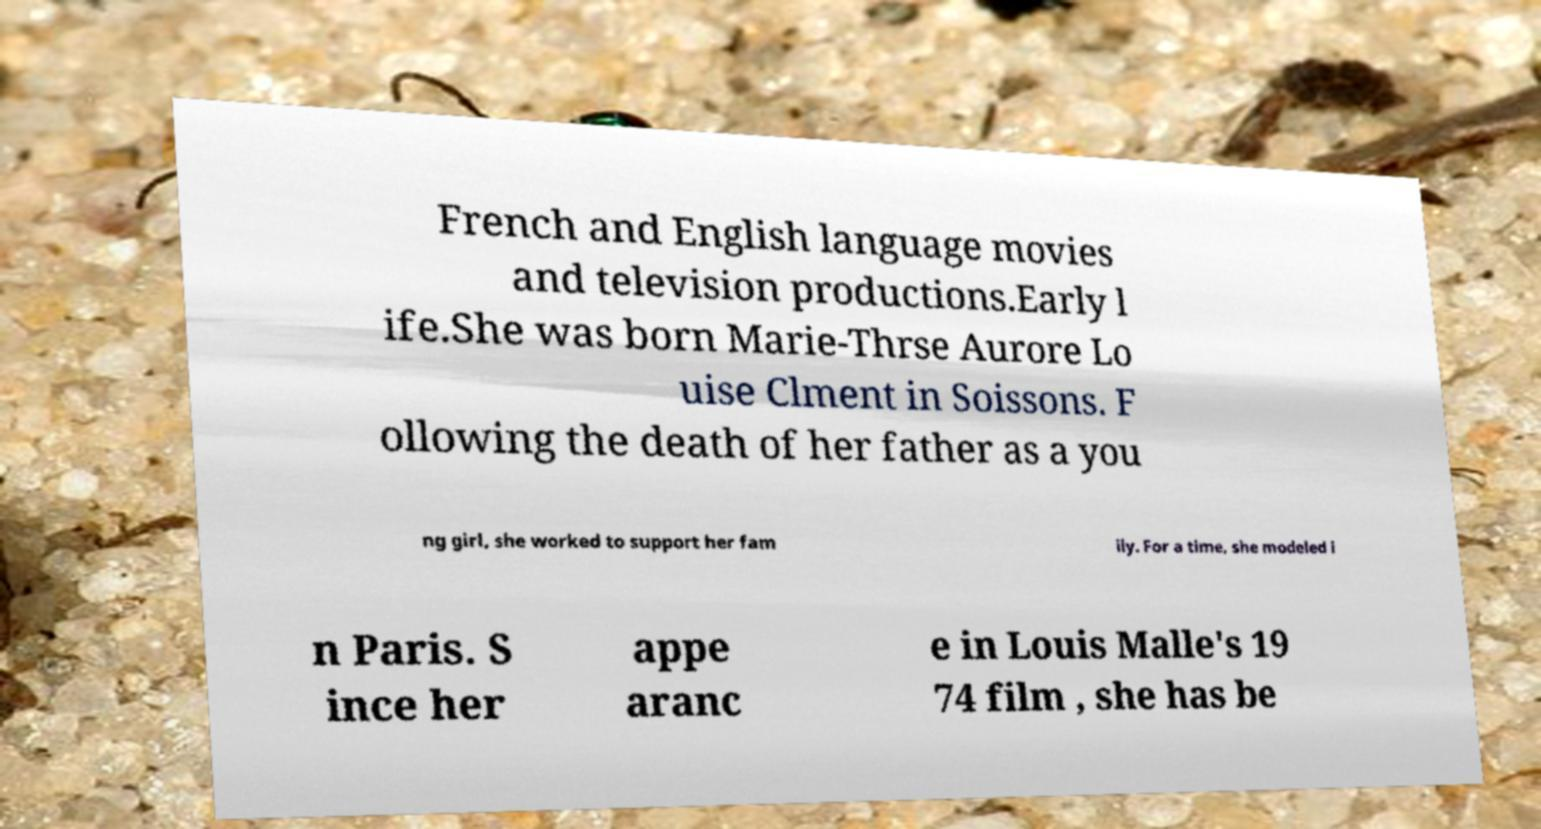Please read and relay the text visible in this image. What does it say? French and English language movies and television productions.Early l ife.She was born Marie-Thrse Aurore Lo uise Clment in Soissons. F ollowing the death of her father as a you ng girl, she worked to support her fam ily. For a time, she modeled i n Paris. S ince her appe aranc e in Louis Malle's 19 74 film , she has be 